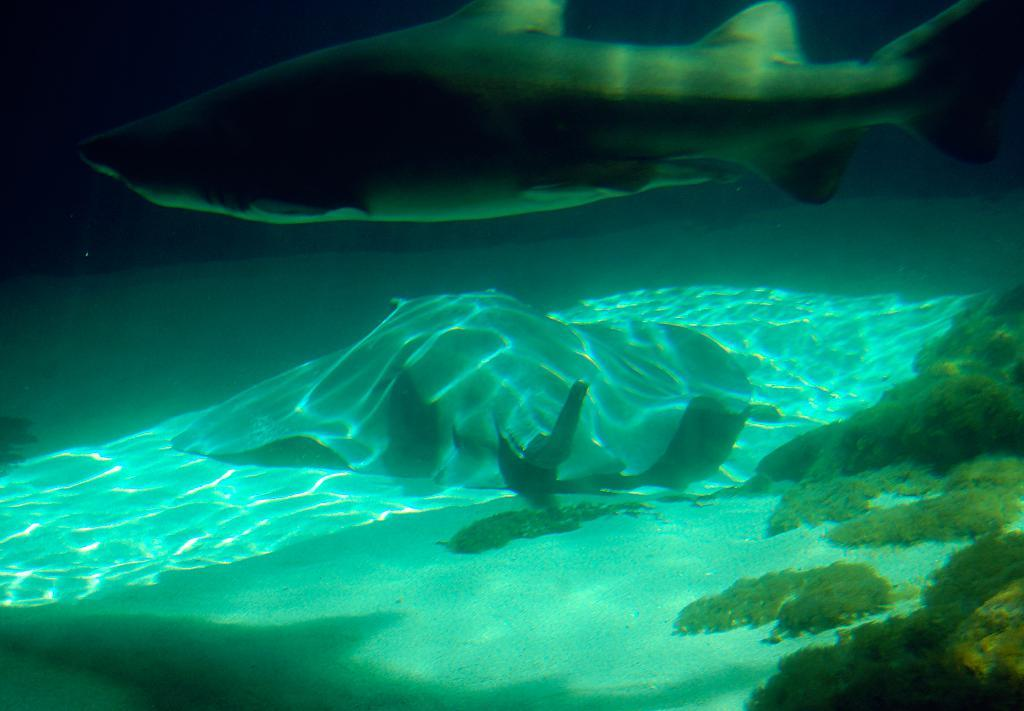What type of animal is in the image? There is a shark in the image. Where is the shark located? The shark is in underwater. What other elements can be seen in the image? There are sea plants in the image. What degree does the shark have in the image? The shark does not have a degree in the image, as it is an animal and not capable of obtaining a degree. 